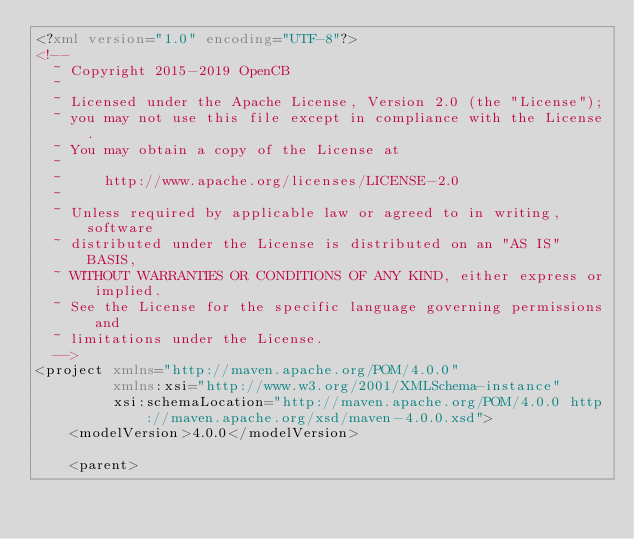<code> <loc_0><loc_0><loc_500><loc_500><_XML_><?xml version="1.0" encoding="UTF-8"?>
<!--
  ~ Copyright 2015-2019 OpenCB
  ~
  ~ Licensed under the Apache License, Version 2.0 (the "License");
  ~ you may not use this file except in compliance with the License.
  ~ You may obtain a copy of the License at
  ~
  ~     http://www.apache.org/licenses/LICENSE-2.0
  ~
  ~ Unless required by applicable law or agreed to in writing, software
  ~ distributed under the License is distributed on an "AS IS" BASIS,
  ~ WITHOUT WARRANTIES OR CONDITIONS OF ANY KIND, either express or implied.
  ~ See the License for the specific language governing permissions and
  ~ limitations under the License.
  -->
<project xmlns="http://maven.apache.org/POM/4.0.0"
         xmlns:xsi="http://www.w3.org/2001/XMLSchema-instance"
         xsi:schemaLocation="http://maven.apache.org/POM/4.0.0 http://maven.apache.org/xsd/maven-4.0.0.xsd">
    <modelVersion>4.0.0</modelVersion>

    <parent></code> 